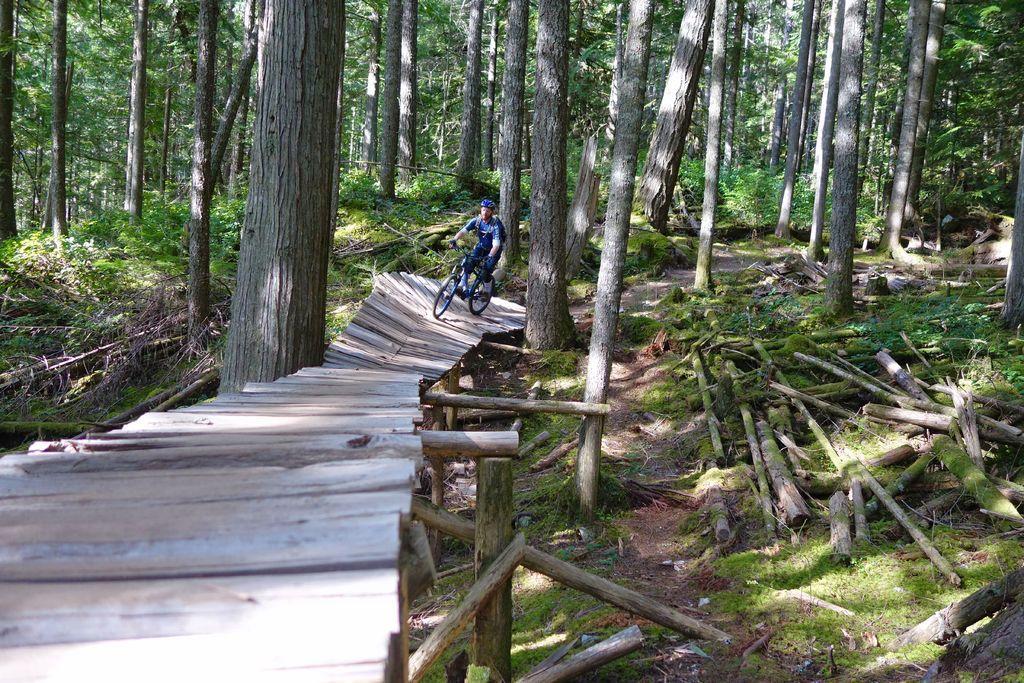Describe this image in one or two sentences. In this picture I can see a person riding bicycle on the wooden bridge. I can see trees in the background. I can see green grass. 